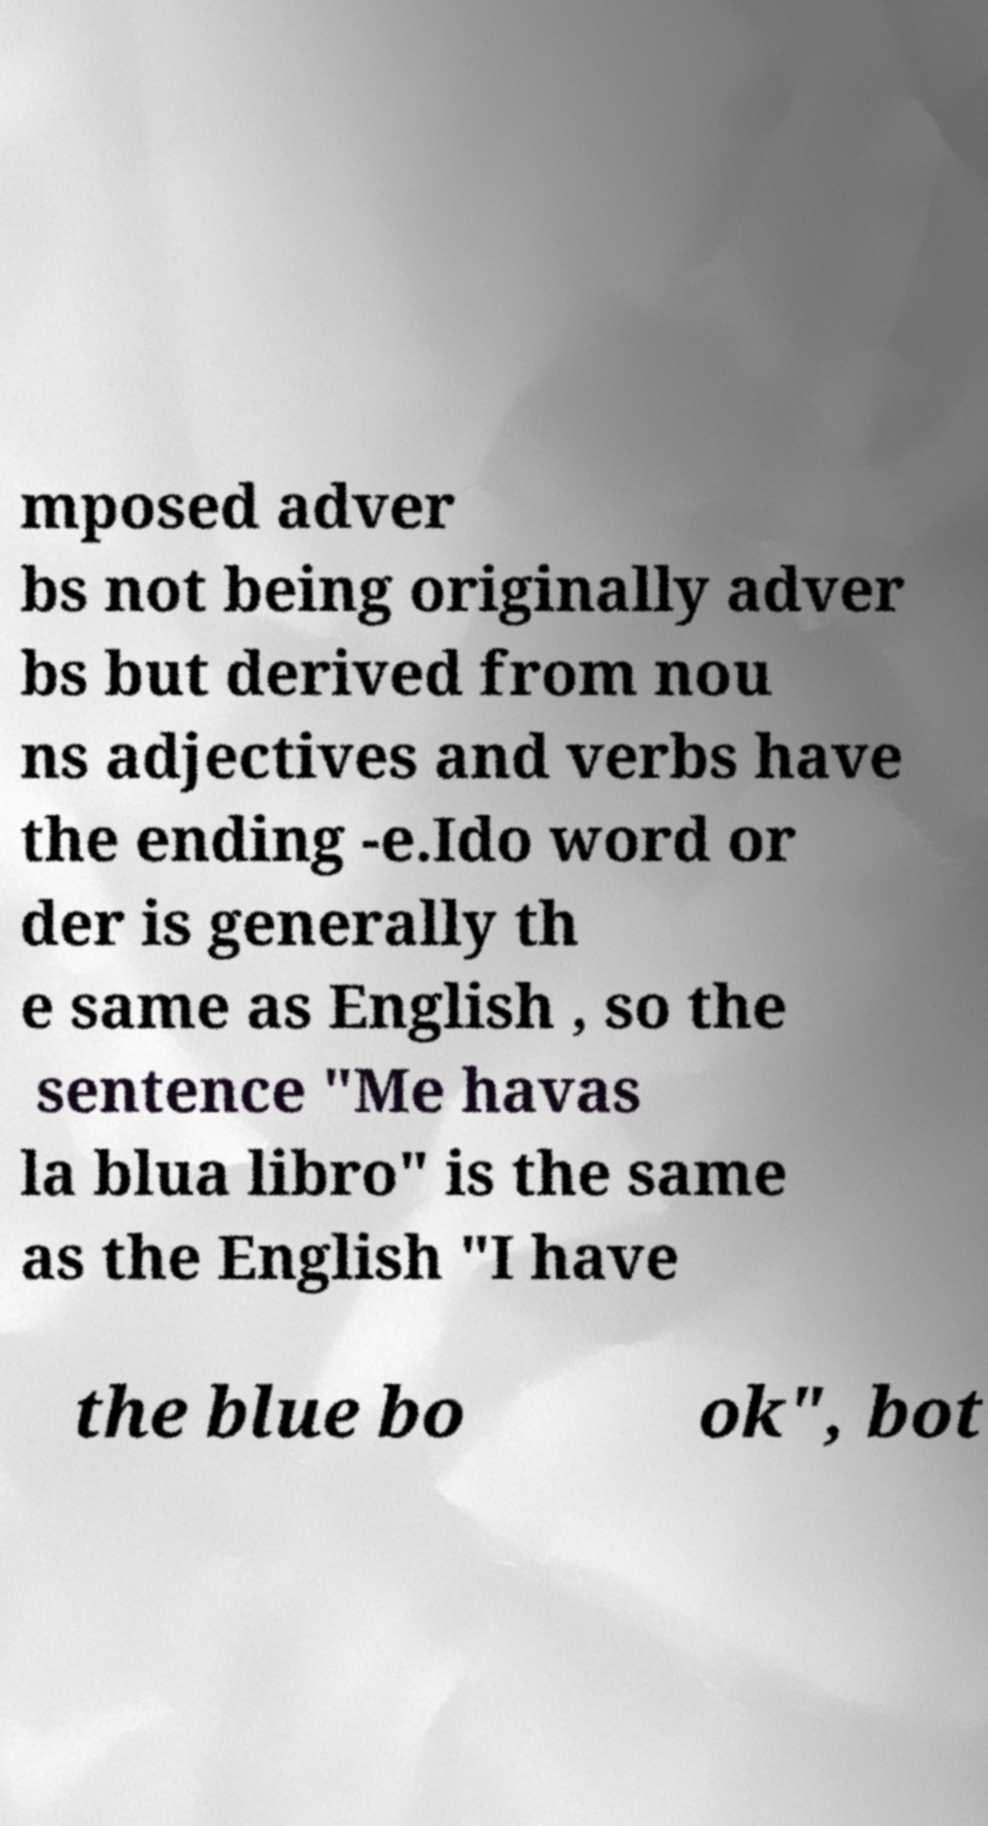What messages or text are displayed in this image? I need them in a readable, typed format. mposed adver bs not being originally adver bs but derived from nou ns adjectives and verbs have the ending -e.Ido word or der is generally th e same as English , so the sentence "Me havas la blua libro" is the same as the English "I have the blue bo ok", bot 